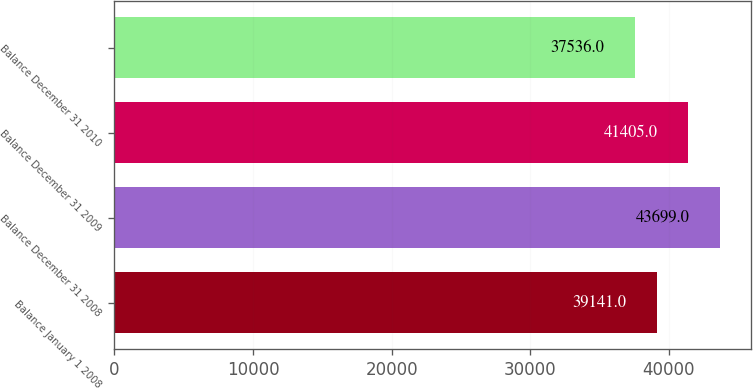<chart> <loc_0><loc_0><loc_500><loc_500><bar_chart><fcel>Balance January 1 2008<fcel>Balance December 31 2008<fcel>Balance December 31 2009<fcel>Balance December 31 2010<nl><fcel>39141<fcel>43699<fcel>41405<fcel>37536<nl></chart> 